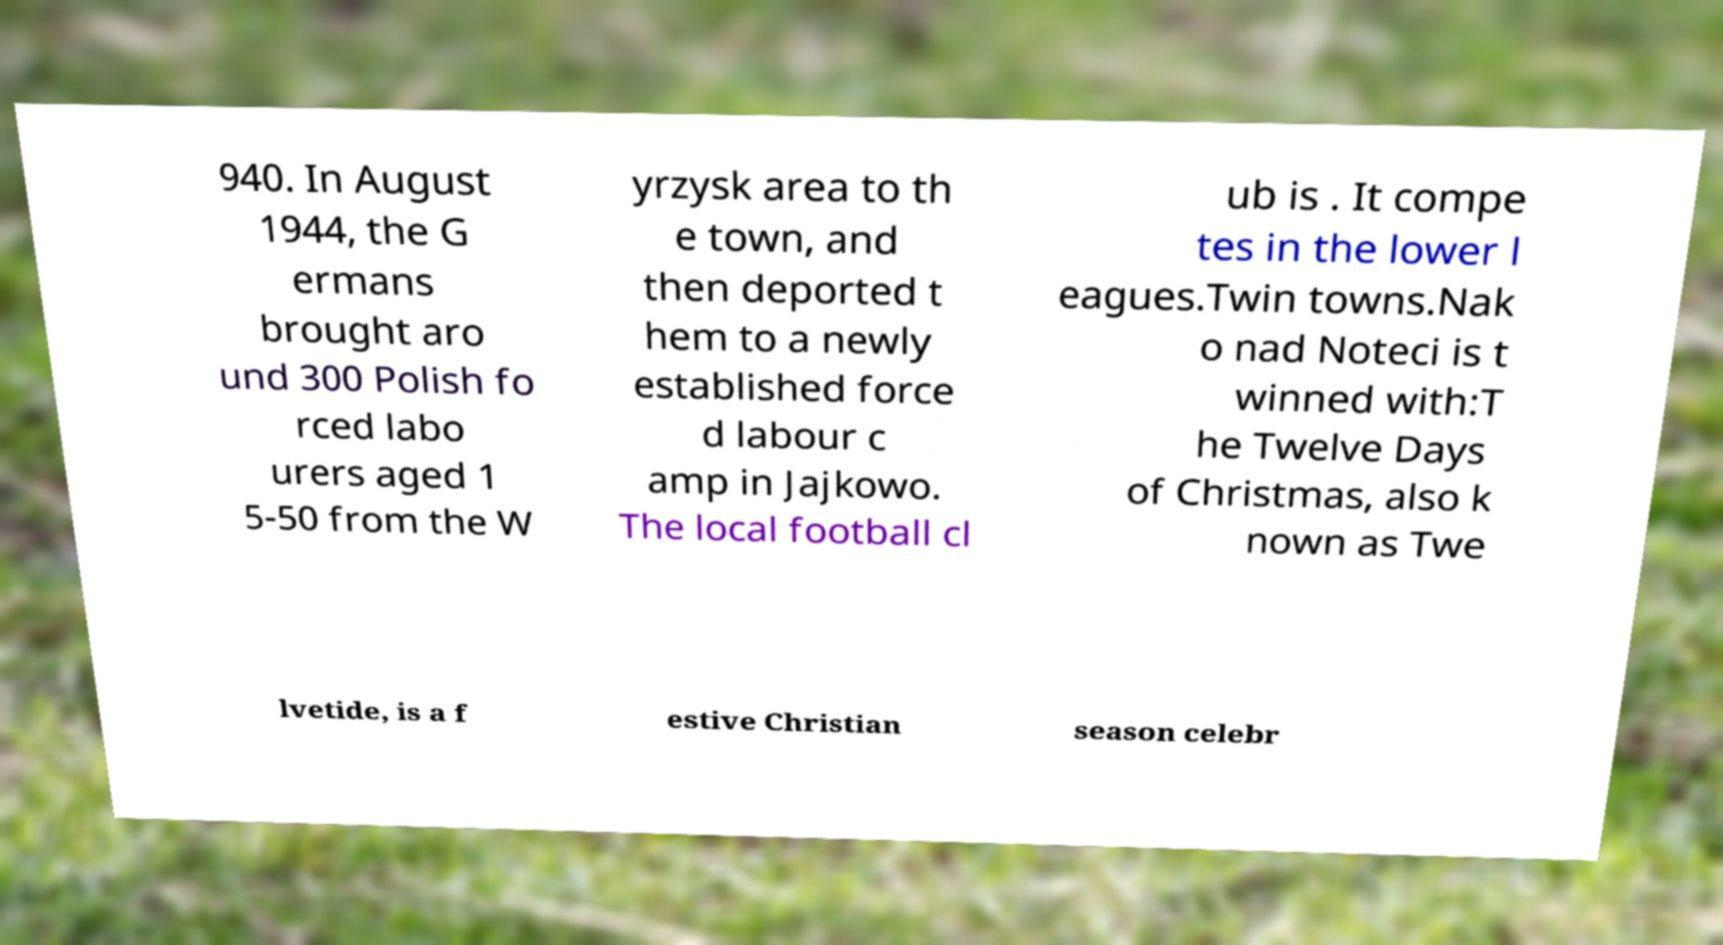Please read and relay the text visible in this image. What does it say? 940. In August 1944, the G ermans brought aro und 300 Polish fo rced labo urers aged 1 5-50 from the W yrzysk area to th e town, and then deported t hem to a newly established force d labour c amp in Jajkowo. The local football cl ub is . It compe tes in the lower l eagues.Twin towns.Nak o nad Noteci is t winned with:T he Twelve Days of Christmas, also k nown as Twe lvetide, is a f estive Christian season celebr 